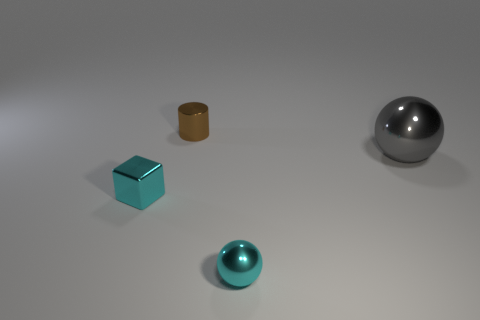What color is the metal sphere on the right side of the small cyan metallic thing that is right of the metal object behind the big gray thing?
Provide a short and direct response. Gray. The metal ball in front of the ball that is right of the cyan ball is what color?
Provide a short and direct response. Cyan. Are there more cyan objects that are to the left of the brown metal thing than gray metal balls on the left side of the shiny block?
Give a very brief answer. Yes. Are there any cyan things to the left of the small cyan cube?
Keep it short and to the point. No. What number of brown objects are cubes or tiny metallic cylinders?
Your answer should be compact. 1. Are the block and the object that is right of the small metallic sphere made of the same material?
Make the answer very short. Yes. The other cyan metal thing that is the same shape as the big object is what size?
Provide a short and direct response. Small. What material is the block?
Your response must be concise. Metal. What is the material of the big ball in front of the shiny thing that is behind the ball behind the cyan sphere?
Give a very brief answer. Metal. Does the object that is behind the big gray thing have the same size as the gray shiny ball to the right of the cylinder?
Provide a short and direct response. No. 